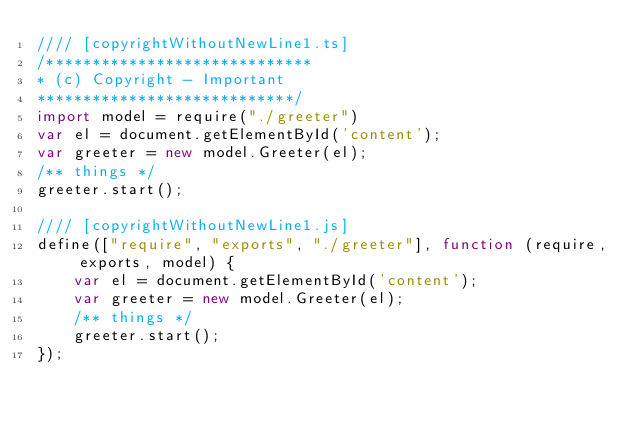Convert code to text. <code><loc_0><loc_0><loc_500><loc_500><_JavaScript_>//// [copyrightWithoutNewLine1.ts]
/*****************************
* (c) Copyright - Important
****************************/
import model = require("./greeter")
var el = document.getElementById('content');
var greeter = new model.Greeter(el);
/** things */
greeter.start();

//// [copyrightWithoutNewLine1.js]
define(["require", "exports", "./greeter"], function (require, exports, model) {
    var el = document.getElementById('content');
    var greeter = new model.Greeter(el);
    /** things */
    greeter.start();
});
</code> 